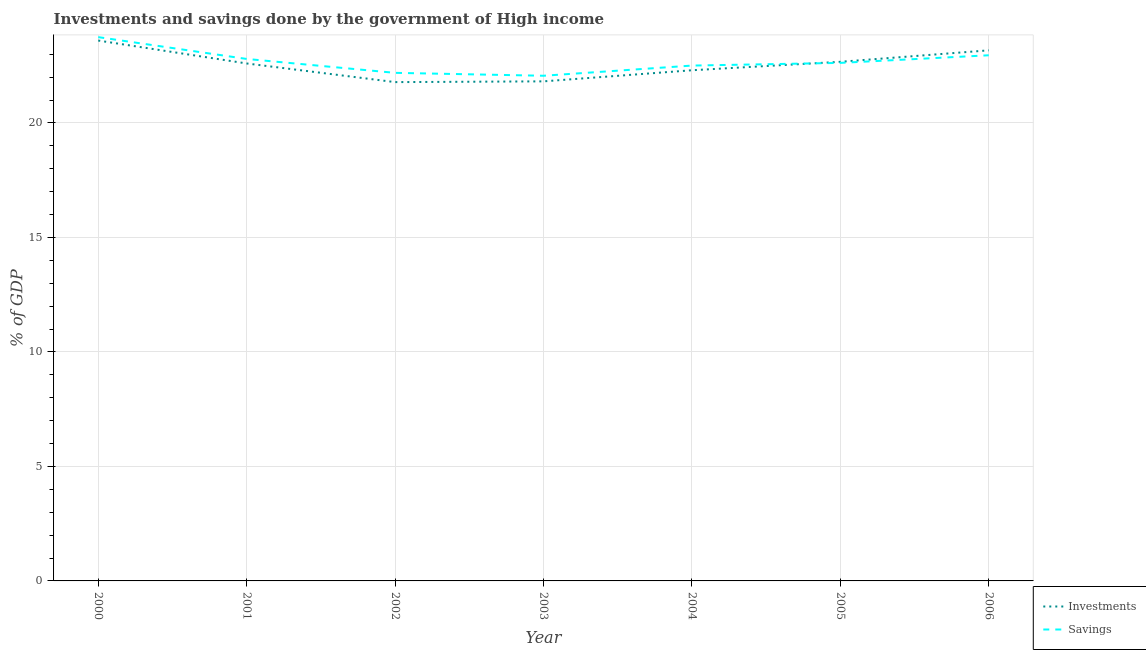What is the investments of government in 2002?
Offer a terse response. 21.79. Across all years, what is the maximum savings of government?
Offer a terse response. 23.75. Across all years, what is the minimum investments of government?
Give a very brief answer. 21.79. What is the total savings of government in the graph?
Provide a short and direct response. 158.89. What is the difference between the investments of government in 2001 and that in 2004?
Provide a succinct answer. 0.3. What is the difference between the savings of government in 2005 and the investments of government in 2000?
Your response must be concise. -0.98. What is the average investments of government per year?
Offer a terse response. 22.57. In the year 2000, what is the difference between the savings of government and investments of government?
Provide a short and direct response. 0.15. In how many years, is the investments of government greater than 13 %?
Ensure brevity in your answer.  7. What is the ratio of the savings of government in 2003 to that in 2005?
Your answer should be compact. 0.98. Is the investments of government in 2000 less than that in 2006?
Offer a terse response. No. Is the difference between the savings of government in 2002 and 2004 greater than the difference between the investments of government in 2002 and 2004?
Your response must be concise. Yes. What is the difference between the highest and the second highest savings of government?
Offer a terse response. 0.79. What is the difference between the highest and the lowest savings of government?
Give a very brief answer. 1.69. In how many years, is the savings of government greater than the average savings of government taken over all years?
Provide a succinct answer. 3. Is the sum of the investments of government in 2003 and 2006 greater than the maximum savings of government across all years?
Your answer should be compact. Yes. Does the investments of government monotonically increase over the years?
Provide a succinct answer. No. Is the investments of government strictly greater than the savings of government over the years?
Your answer should be very brief. No. Is the investments of government strictly less than the savings of government over the years?
Your answer should be compact. No. How many lines are there?
Your answer should be compact. 2. Does the graph contain any zero values?
Keep it short and to the point. No. Does the graph contain grids?
Ensure brevity in your answer.  Yes. Where does the legend appear in the graph?
Ensure brevity in your answer.  Bottom right. How many legend labels are there?
Your answer should be very brief. 2. How are the legend labels stacked?
Offer a very short reply. Vertical. What is the title of the graph?
Your response must be concise. Investments and savings done by the government of High income. Does "Food" appear as one of the legend labels in the graph?
Provide a short and direct response. No. What is the label or title of the Y-axis?
Keep it short and to the point. % of GDP. What is the % of GDP of Investments in 2000?
Provide a succinct answer. 23.6. What is the % of GDP in Savings in 2000?
Keep it short and to the point. 23.75. What is the % of GDP of Investments in 2001?
Keep it short and to the point. 22.6. What is the % of GDP in Savings in 2001?
Your response must be concise. 22.8. What is the % of GDP of Investments in 2002?
Make the answer very short. 21.79. What is the % of GDP in Savings in 2002?
Provide a succinct answer. 22.19. What is the % of GDP in Investments in 2003?
Offer a very short reply. 21.82. What is the % of GDP in Savings in 2003?
Your answer should be compact. 22.06. What is the % of GDP of Investments in 2004?
Offer a terse response. 22.3. What is the % of GDP of Savings in 2004?
Provide a succinct answer. 22.51. What is the % of GDP of Investments in 2005?
Keep it short and to the point. 22.67. What is the % of GDP of Savings in 2005?
Your response must be concise. 22.63. What is the % of GDP in Investments in 2006?
Your response must be concise. 23.17. What is the % of GDP in Savings in 2006?
Provide a short and direct response. 22.96. Across all years, what is the maximum % of GDP in Investments?
Make the answer very short. 23.6. Across all years, what is the maximum % of GDP of Savings?
Keep it short and to the point. 23.75. Across all years, what is the minimum % of GDP of Investments?
Offer a very short reply. 21.79. Across all years, what is the minimum % of GDP of Savings?
Provide a succinct answer. 22.06. What is the total % of GDP of Investments in the graph?
Your answer should be very brief. 157.96. What is the total % of GDP of Savings in the graph?
Make the answer very short. 158.89. What is the difference between the % of GDP in Investments in 2000 and that in 2001?
Your response must be concise. 1. What is the difference between the % of GDP in Savings in 2000 and that in 2001?
Offer a very short reply. 0.95. What is the difference between the % of GDP in Investments in 2000 and that in 2002?
Offer a very short reply. 1.82. What is the difference between the % of GDP of Savings in 2000 and that in 2002?
Give a very brief answer. 1.56. What is the difference between the % of GDP in Investments in 2000 and that in 2003?
Make the answer very short. 1.78. What is the difference between the % of GDP of Savings in 2000 and that in 2003?
Offer a terse response. 1.69. What is the difference between the % of GDP of Investments in 2000 and that in 2004?
Provide a short and direct response. 1.3. What is the difference between the % of GDP of Savings in 2000 and that in 2004?
Your answer should be compact. 1.24. What is the difference between the % of GDP of Savings in 2000 and that in 2005?
Your response must be concise. 1.12. What is the difference between the % of GDP of Investments in 2000 and that in 2006?
Offer a very short reply. 0.43. What is the difference between the % of GDP in Savings in 2000 and that in 2006?
Keep it short and to the point. 0.79. What is the difference between the % of GDP in Investments in 2001 and that in 2002?
Keep it short and to the point. 0.81. What is the difference between the % of GDP of Savings in 2001 and that in 2002?
Offer a terse response. 0.61. What is the difference between the % of GDP of Investments in 2001 and that in 2003?
Your answer should be very brief. 0.78. What is the difference between the % of GDP of Savings in 2001 and that in 2003?
Provide a succinct answer. 0.73. What is the difference between the % of GDP in Investments in 2001 and that in 2004?
Keep it short and to the point. 0.3. What is the difference between the % of GDP in Savings in 2001 and that in 2004?
Make the answer very short. 0.29. What is the difference between the % of GDP in Investments in 2001 and that in 2005?
Your response must be concise. -0.07. What is the difference between the % of GDP of Savings in 2001 and that in 2005?
Make the answer very short. 0.17. What is the difference between the % of GDP in Investments in 2001 and that in 2006?
Keep it short and to the point. -0.57. What is the difference between the % of GDP of Savings in 2001 and that in 2006?
Make the answer very short. -0.16. What is the difference between the % of GDP of Investments in 2002 and that in 2003?
Offer a terse response. -0.03. What is the difference between the % of GDP of Savings in 2002 and that in 2003?
Your answer should be compact. 0.13. What is the difference between the % of GDP in Investments in 2002 and that in 2004?
Offer a very short reply. -0.52. What is the difference between the % of GDP in Savings in 2002 and that in 2004?
Offer a very short reply. -0.32. What is the difference between the % of GDP of Investments in 2002 and that in 2005?
Your response must be concise. -0.89. What is the difference between the % of GDP in Savings in 2002 and that in 2005?
Your answer should be very brief. -0.44. What is the difference between the % of GDP of Investments in 2002 and that in 2006?
Ensure brevity in your answer.  -1.39. What is the difference between the % of GDP of Savings in 2002 and that in 2006?
Your response must be concise. -0.77. What is the difference between the % of GDP of Investments in 2003 and that in 2004?
Offer a terse response. -0.48. What is the difference between the % of GDP in Savings in 2003 and that in 2004?
Offer a terse response. -0.44. What is the difference between the % of GDP of Investments in 2003 and that in 2005?
Make the answer very short. -0.85. What is the difference between the % of GDP in Savings in 2003 and that in 2005?
Ensure brevity in your answer.  -0.56. What is the difference between the % of GDP of Investments in 2003 and that in 2006?
Offer a very short reply. -1.36. What is the difference between the % of GDP of Savings in 2003 and that in 2006?
Provide a succinct answer. -0.89. What is the difference between the % of GDP in Investments in 2004 and that in 2005?
Your answer should be compact. -0.37. What is the difference between the % of GDP in Savings in 2004 and that in 2005?
Provide a short and direct response. -0.12. What is the difference between the % of GDP of Investments in 2004 and that in 2006?
Offer a terse response. -0.87. What is the difference between the % of GDP of Savings in 2004 and that in 2006?
Provide a short and direct response. -0.45. What is the difference between the % of GDP in Investments in 2005 and that in 2006?
Provide a succinct answer. -0.5. What is the difference between the % of GDP of Savings in 2005 and that in 2006?
Your answer should be very brief. -0.33. What is the difference between the % of GDP in Investments in 2000 and the % of GDP in Savings in 2001?
Provide a short and direct response. 0.8. What is the difference between the % of GDP of Investments in 2000 and the % of GDP of Savings in 2002?
Offer a very short reply. 1.41. What is the difference between the % of GDP in Investments in 2000 and the % of GDP in Savings in 2003?
Your answer should be very brief. 1.54. What is the difference between the % of GDP in Investments in 2000 and the % of GDP in Savings in 2004?
Provide a succinct answer. 1.09. What is the difference between the % of GDP of Investments in 2000 and the % of GDP of Savings in 2005?
Make the answer very short. 0.98. What is the difference between the % of GDP of Investments in 2000 and the % of GDP of Savings in 2006?
Ensure brevity in your answer.  0.64. What is the difference between the % of GDP in Investments in 2001 and the % of GDP in Savings in 2002?
Ensure brevity in your answer.  0.41. What is the difference between the % of GDP in Investments in 2001 and the % of GDP in Savings in 2003?
Keep it short and to the point. 0.54. What is the difference between the % of GDP in Investments in 2001 and the % of GDP in Savings in 2004?
Make the answer very short. 0.09. What is the difference between the % of GDP in Investments in 2001 and the % of GDP in Savings in 2005?
Offer a terse response. -0.03. What is the difference between the % of GDP of Investments in 2001 and the % of GDP of Savings in 2006?
Provide a short and direct response. -0.36. What is the difference between the % of GDP in Investments in 2002 and the % of GDP in Savings in 2003?
Provide a short and direct response. -0.28. What is the difference between the % of GDP of Investments in 2002 and the % of GDP of Savings in 2004?
Make the answer very short. -0.72. What is the difference between the % of GDP in Investments in 2002 and the % of GDP in Savings in 2005?
Your answer should be very brief. -0.84. What is the difference between the % of GDP of Investments in 2002 and the % of GDP of Savings in 2006?
Offer a very short reply. -1.17. What is the difference between the % of GDP in Investments in 2003 and the % of GDP in Savings in 2004?
Offer a terse response. -0.69. What is the difference between the % of GDP of Investments in 2003 and the % of GDP of Savings in 2005?
Offer a terse response. -0.81. What is the difference between the % of GDP of Investments in 2003 and the % of GDP of Savings in 2006?
Provide a succinct answer. -1.14. What is the difference between the % of GDP in Investments in 2004 and the % of GDP in Savings in 2005?
Provide a succinct answer. -0.32. What is the difference between the % of GDP of Investments in 2004 and the % of GDP of Savings in 2006?
Provide a succinct answer. -0.65. What is the difference between the % of GDP in Investments in 2005 and the % of GDP in Savings in 2006?
Give a very brief answer. -0.29. What is the average % of GDP in Investments per year?
Make the answer very short. 22.57. What is the average % of GDP in Savings per year?
Your answer should be very brief. 22.7. In the year 2000, what is the difference between the % of GDP of Investments and % of GDP of Savings?
Give a very brief answer. -0.15. In the year 2001, what is the difference between the % of GDP in Investments and % of GDP in Savings?
Your answer should be very brief. -0.2. In the year 2002, what is the difference between the % of GDP in Investments and % of GDP in Savings?
Give a very brief answer. -0.4. In the year 2003, what is the difference between the % of GDP of Investments and % of GDP of Savings?
Make the answer very short. -0.24. In the year 2004, what is the difference between the % of GDP of Investments and % of GDP of Savings?
Your answer should be very brief. -0.2. In the year 2005, what is the difference between the % of GDP in Investments and % of GDP in Savings?
Offer a very short reply. 0.05. In the year 2006, what is the difference between the % of GDP of Investments and % of GDP of Savings?
Your answer should be very brief. 0.22. What is the ratio of the % of GDP in Investments in 2000 to that in 2001?
Ensure brevity in your answer.  1.04. What is the ratio of the % of GDP of Savings in 2000 to that in 2001?
Your answer should be very brief. 1.04. What is the ratio of the % of GDP of Savings in 2000 to that in 2002?
Your answer should be compact. 1.07. What is the ratio of the % of GDP of Investments in 2000 to that in 2003?
Offer a terse response. 1.08. What is the ratio of the % of GDP in Savings in 2000 to that in 2003?
Ensure brevity in your answer.  1.08. What is the ratio of the % of GDP of Investments in 2000 to that in 2004?
Your answer should be compact. 1.06. What is the ratio of the % of GDP in Savings in 2000 to that in 2004?
Keep it short and to the point. 1.06. What is the ratio of the % of GDP of Investments in 2000 to that in 2005?
Your answer should be compact. 1.04. What is the ratio of the % of GDP of Savings in 2000 to that in 2005?
Keep it short and to the point. 1.05. What is the ratio of the % of GDP of Investments in 2000 to that in 2006?
Your answer should be compact. 1.02. What is the ratio of the % of GDP in Savings in 2000 to that in 2006?
Make the answer very short. 1.03. What is the ratio of the % of GDP of Investments in 2001 to that in 2002?
Offer a terse response. 1.04. What is the ratio of the % of GDP of Savings in 2001 to that in 2002?
Your answer should be compact. 1.03. What is the ratio of the % of GDP in Investments in 2001 to that in 2003?
Your answer should be very brief. 1.04. What is the ratio of the % of GDP of Investments in 2001 to that in 2004?
Keep it short and to the point. 1.01. What is the ratio of the % of GDP of Savings in 2001 to that in 2004?
Ensure brevity in your answer.  1.01. What is the ratio of the % of GDP of Investments in 2001 to that in 2005?
Ensure brevity in your answer.  1. What is the ratio of the % of GDP of Savings in 2001 to that in 2005?
Make the answer very short. 1.01. What is the ratio of the % of GDP of Investments in 2001 to that in 2006?
Make the answer very short. 0.98. What is the ratio of the % of GDP of Investments in 2002 to that in 2004?
Provide a succinct answer. 0.98. What is the ratio of the % of GDP of Savings in 2002 to that in 2004?
Provide a short and direct response. 0.99. What is the ratio of the % of GDP in Investments in 2002 to that in 2005?
Your answer should be compact. 0.96. What is the ratio of the % of GDP in Savings in 2002 to that in 2005?
Give a very brief answer. 0.98. What is the ratio of the % of GDP of Investments in 2002 to that in 2006?
Give a very brief answer. 0.94. What is the ratio of the % of GDP in Savings in 2002 to that in 2006?
Keep it short and to the point. 0.97. What is the ratio of the % of GDP in Investments in 2003 to that in 2004?
Offer a terse response. 0.98. What is the ratio of the % of GDP in Savings in 2003 to that in 2004?
Provide a succinct answer. 0.98. What is the ratio of the % of GDP in Investments in 2003 to that in 2005?
Provide a short and direct response. 0.96. What is the ratio of the % of GDP of Savings in 2003 to that in 2005?
Your answer should be very brief. 0.98. What is the ratio of the % of GDP of Investments in 2003 to that in 2006?
Provide a short and direct response. 0.94. What is the ratio of the % of GDP in Savings in 2003 to that in 2006?
Provide a short and direct response. 0.96. What is the ratio of the % of GDP of Investments in 2004 to that in 2005?
Your answer should be compact. 0.98. What is the ratio of the % of GDP of Savings in 2004 to that in 2005?
Ensure brevity in your answer.  0.99. What is the ratio of the % of GDP of Investments in 2004 to that in 2006?
Offer a terse response. 0.96. What is the ratio of the % of GDP of Savings in 2004 to that in 2006?
Give a very brief answer. 0.98. What is the ratio of the % of GDP of Investments in 2005 to that in 2006?
Your response must be concise. 0.98. What is the ratio of the % of GDP of Savings in 2005 to that in 2006?
Offer a terse response. 0.99. What is the difference between the highest and the second highest % of GDP in Investments?
Provide a succinct answer. 0.43. What is the difference between the highest and the second highest % of GDP in Savings?
Offer a terse response. 0.79. What is the difference between the highest and the lowest % of GDP of Investments?
Provide a succinct answer. 1.82. What is the difference between the highest and the lowest % of GDP of Savings?
Offer a very short reply. 1.69. 